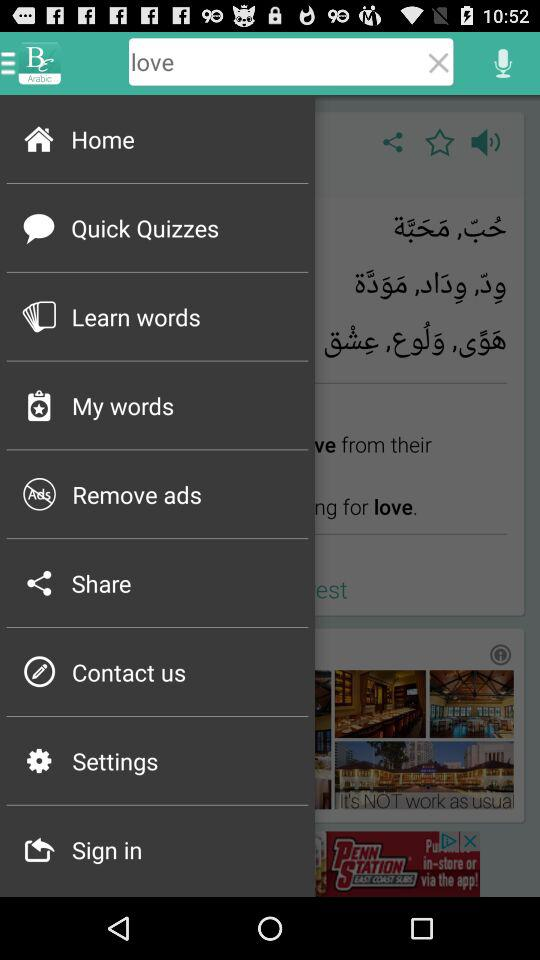What is the name of the application? The name of the application is "Be Arabic". 